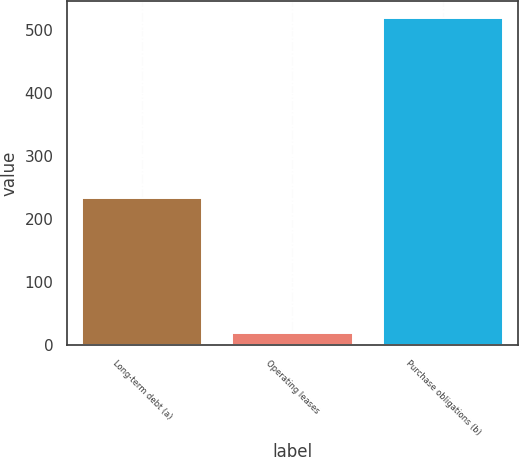Convert chart to OTSL. <chart><loc_0><loc_0><loc_500><loc_500><bar_chart><fcel>Long-term debt (a)<fcel>Operating leases<fcel>Purchase obligations (b)<nl><fcel>234<fcel>19<fcel>519<nl></chart> 